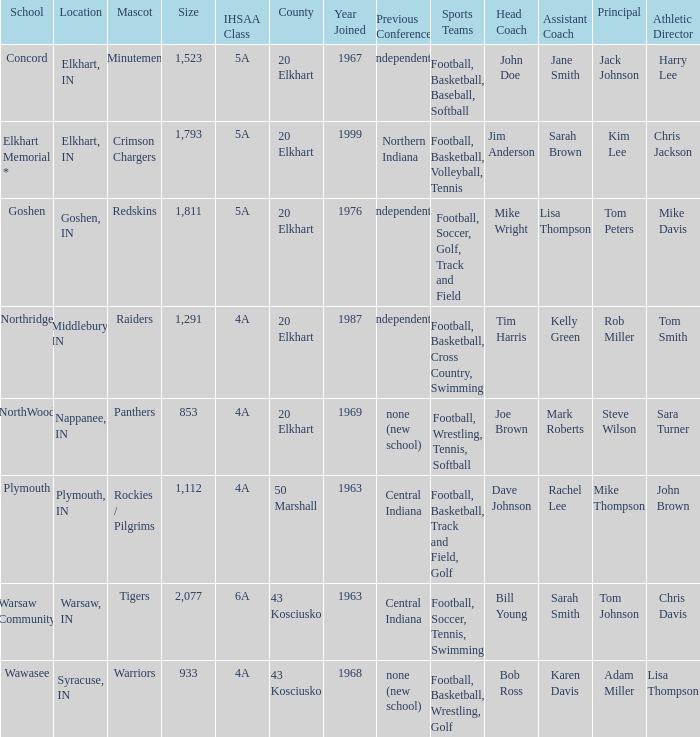What is the IHSAA class for the team located in Middlebury, IN? 4A. 